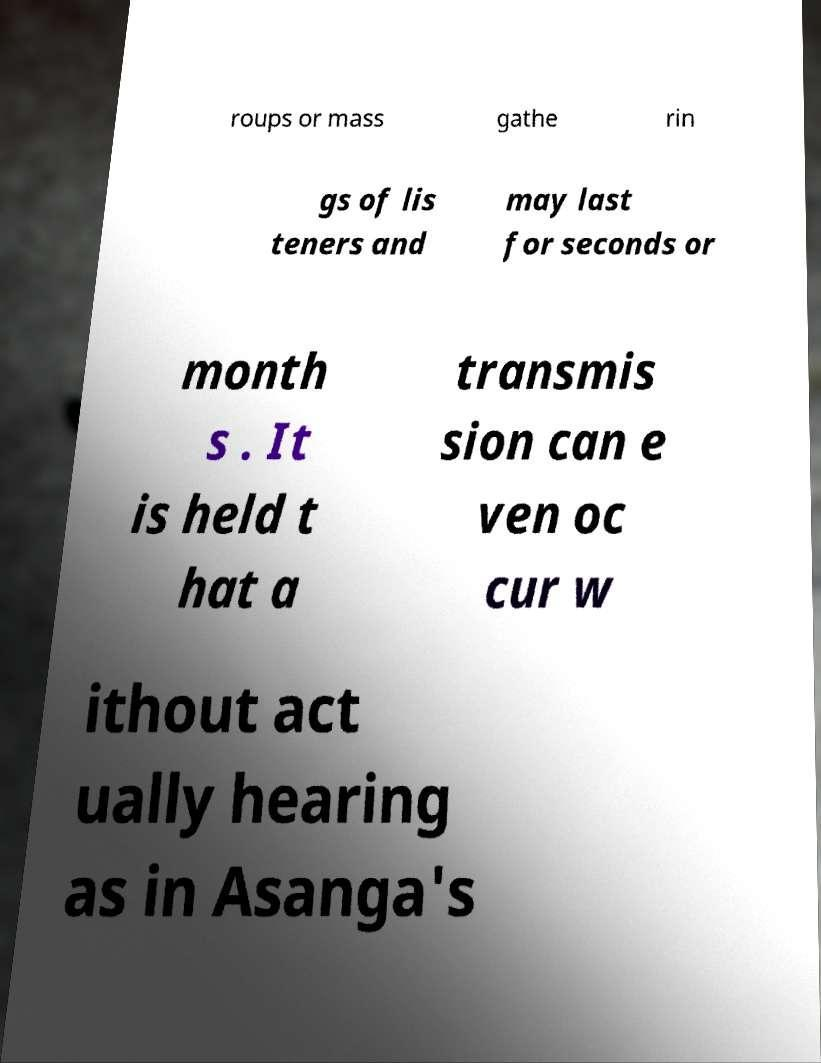What messages or text are displayed in this image? I need them in a readable, typed format. roups or mass gathe rin gs of lis teners and may last for seconds or month s . It is held t hat a transmis sion can e ven oc cur w ithout act ually hearing as in Asanga's 